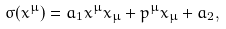<formula> <loc_0><loc_0><loc_500><loc_500>\sigma ( x ^ { \mu } ) = a _ { 1 } x ^ { \mu } x _ { \mu } + p ^ { \mu } x _ { \mu } + a _ { 2 } ,</formula> 